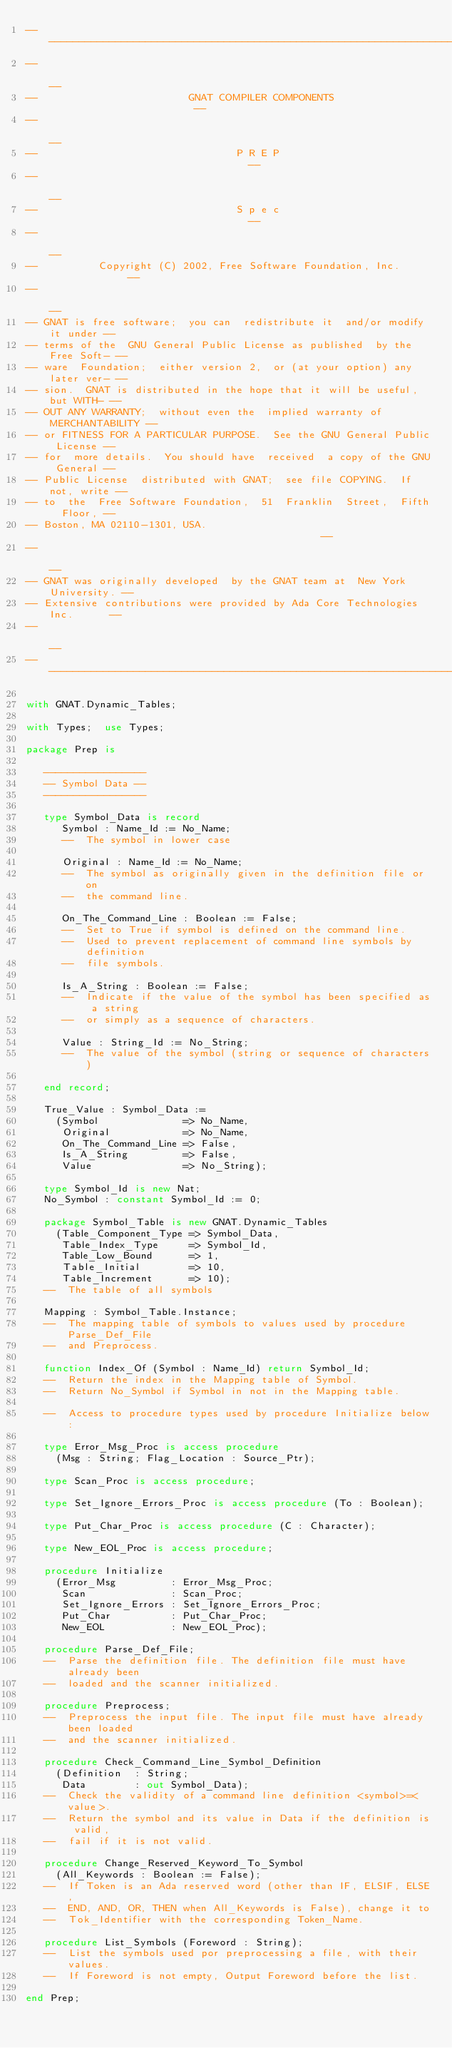<code> <loc_0><loc_0><loc_500><loc_500><_Ada_>------------------------------------------------------------------------------
--                                                                          --
--                         GNAT COMPILER COMPONENTS                         --
--                                                                          --
--                                 P R E P                                  --
--                                                                          --
--                                 S p e c                                  --
--                                                                          --
--          Copyright (C) 2002, Free Software Foundation, Inc.              --
--                                                                          --
-- GNAT is free software;  you can  redistribute it  and/or modify it under --
-- terms of the  GNU General Public License as published  by the Free Soft- --
-- ware  Foundation;  either version 2,  or (at your option) any later ver- --
-- sion.  GNAT is distributed in the hope that it will be useful, but WITH- --
-- OUT ANY WARRANTY;  without even the  implied warranty of MERCHANTABILITY --
-- or FITNESS FOR A PARTICULAR PURPOSE.  See the GNU General Public License --
-- for  more details.  You should have  received  a copy of the GNU General --
-- Public License  distributed with GNAT;  see file COPYING.  If not, write --
-- to  the  Free Software Foundation,  51  Franklin  Street,  Fifth  Floor, --
-- Boston, MA 02110-1301, USA.                                              --
--                                                                          --
-- GNAT was originally developed  by the GNAT team at  New York University. --
-- Extensive contributions were provided by Ada Core Technologies Inc.      --
--                                                                          --
------------------------------------------------------------------------------

with GNAT.Dynamic_Tables;

with Types;  use Types;

package Prep is

   -----------------
   -- Symbol Data --
   -----------------

   type Symbol_Data is record
      Symbol : Name_Id := No_Name;
      --  The symbol in lower case

      Original : Name_Id := No_Name;
      --  The symbol as originally given in the definition file or on
      --  the command line.

      On_The_Command_Line : Boolean := False;
      --  Set to True if symbol is defined on the command line.
      --  Used to prevent replacement of command line symbols by definition
      --  file symbols.

      Is_A_String : Boolean := False;
      --  Indicate if the value of the symbol has been specified as a string
      --  or simply as a sequence of characters.

      Value : String_Id := No_String;
      --  The value of the symbol (string or sequence of characters)

   end record;

   True_Value : Symbol_Data :=
     (Symbol              => No_Name,
      Original            => No_Name,
      On_The_Command_Line => False,
      Is_A_String         => False,
      Value               => No_String);

   type Symbol_Id is new Nat;
   No_Symbol : constant Symbol_Id := 0;

   package Symbol_Table is new GNAT.Dynamic_Tables
     (Table_Component_Type => Symbol_Data,
      Table_Index_Type     => Symbol_Id,
      Table_Low_Bound      => 1,
      Table_Initial        => 10,
      Table_Increment      => 10);
   --  The table of all symbols

   Mapping : Symbol_Table.Instance;
   --  The mapping table of symbols to values used by procedure Parse_Def_File
   --  and Preprocess.

   function Index_Of (Symbol : Name_Id) return Symbol_Id;
   --  Return the index in the Mapping table of Symbol.
   --  Return No_Symbol if Symbol in not in the Mapping table.

   --  Access to procedure types used by procedure Initialize below:

   type Error_Msg_Proc is access procedure
     (Msg : String; Flag_Location : Source_Ptr);

   type Scan_Proc is access procedure;

   type Set_Ignore_Errors_Proc is access procedure (To : Boolean);

   type Put_Char_Proc is access procedure (C : Character);

   type New_EOL_Proc is access procedure;

   procedure Initialize
     (Error_Msg         : Error_Msg_Proc;
      Scan              : Scan_Proc;
      Set_Ignore_Errors : Set_Ignore_Errors_Proc;
      Put_Char          : Put_Char_Proc;
      New_EOL           : New_EOL_Proc);

   procedure Parse_Def_File;
   --  Parse the definition file. The definition file must have already been
   --  loaded and the scanner initialized.

   procedure Preprocess;
   --  Preprocess the input file. The input file must have already been loaded
   --  and the scanner initialized.

   procedure Check_Command_Line_Symbol_Definition
     (Definition  : String;
      Data        : out Symbol_Data);
   --  Check the validity of a command line definition <symbol>=<value>.
   --  Return the symbol and its value in Data if the definition is valid,
   --  fail if it is not valid.

   procedure Change_Reserved_Keyword_To_Symbol
     (All_Keywords : Boolean := False);
   --  If Token is an Ada reserved word (other than IF, ELSIF, ELSE,
   --  END, AND, OR, THEN when All_Keywords is False), change it to
   --  Tok_Identifier with the corresponding Token_Name.

   procedure List_Symbols (Foreword : String);
   --  List the symbols used por preprocessing a file, with their values.
   --  If Foreword is not empty, Output Foreword before the list.

end Prep;
</code> 